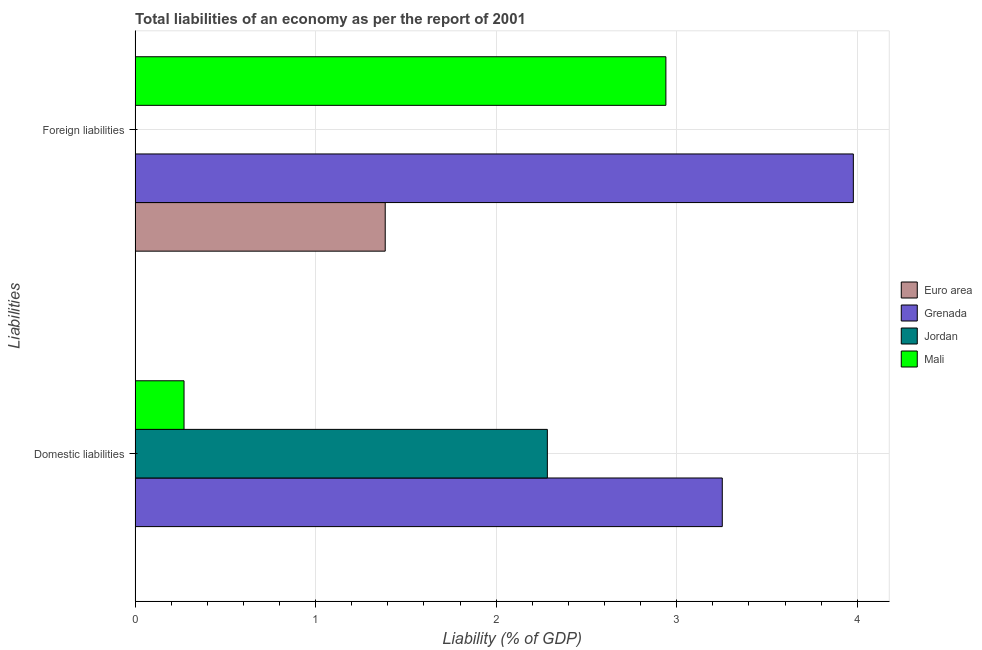How many different coloured bars are there?
Provide a short and direct response. 4. How many groups of bars are there?
Your response must be concise. 2. Are the number of bars per tick equal to the number of legend labels?
Ensure brevity in your answer.  No. Are the number of bars on each tick of the Y-axis equal?
Give a very brief answer. Yes. What is the label of the 1st group of bars from the top?
Provide a short and direct response. Foreign liabilities. What is the incurrence of domestic liabilities in Euro area?
Offer a terse response. 0. Across all countries, what is the maximum incurrence of foreign liabilities?
Offer a terse response. 3.98. In which country was the incurrence of domestic liabilities maximum?
Your answer should be compact. Grenada. What is the total incurrence of domestic liabilities in the graph?
Your answer should be compact. 5.81. What is the difference between the incurrence of domestic liabilities in Mali and that in Jordan?
Provide a short and direct response. -2.01. What is the difference between the incurrence of domestic liabilities in Grenada and the incurrence of foreign liabilities in Mali?
Your answer should be very brief. 0.31. What is the average incurrence of foreign liabilities per country?
Your response must be concise. 2.08. What is the difference between the incurrence of domestic liabilities and incurrence of foreign liabilities in Grenada?
Your answer should be very brief. -0.73. What is the ratio of the incurrence of domestic liabilities in Jordan to that in Grenada?
Your response must be concise. 0.7. Is the incurrence of foreign liabilities in Euro area less than that in Grenada?
Ensure brevity in your answer.  Yes. In how many countries, is the incurrence of foreign liabilities greater than the average incurrence of foreign liabilities taken over all countries?
Keep it short and to the point. 2. How many bars are there?
Provide a short and direct response. 6. Are all the bars in the graph horizontal?
Offer a terse response. Yes. Are the values on the major ticks of X-axis written in scientific E-notation?
Provide a short and direct response. No. Does the graph contain any zero values?
Your answer should be compact. Yes. Where does the legend appear in the graph?
Offer a terse response. Center right. How many legend labels are there?
Offer a terse response. 4. How are the legend labels stacked?
Your answer should be very brief. Vertical. What is the title of the graph?
Provide a short and direct response. Total liabilities of an economy as per the report of 2001. Does "Puerto Rico" appear as one of the legend labels in the graph?
Make the answer very short. No. What is the label or title of the X-axis?
Offer a terse response. Liability (% of GDP). What is the label or title of the Y-axis?
Your response must be concise. Liabilities. What is the Liability (% of GDP) of Grenada in Domestic liabilities?
Ensure brevity in your answer.  3.25. What is the Liability (% of GDP) in Jordan in Domestic liabilities?
Keep it short and to the point. 2.28. What is the Liability (% of GDP) of Mali in Domestic liabilities?
Your response must be concise. 0.27. What is the Liability (% of GDP) in Euro area in Foreign liabilities?
Provide a short and direct response. 1.39. What is the Liability (% of GDP) of Grenada in Foreign liabilities?
Offer a terse response. 3.98. What is the Liability (% of GDP) in Mali in Foreign liabilities?
Offer a very short reply. 2.94. Across all Liabilities, what is the maximum Liability (% of GDP) in Euro area?
Ensure brevity in your answer.  1.39. Across all Liabilities, what is the maximum Liability (% of GDP) in Grenada?
Your answer should be very brief. 3.98. Across all Liabilities, what is the maximum Liability (% of GDP) of Jordan?
Ensure brevity in your answer.  2.28. Across all Liabilities, what is the maximum Liability (% of GDP) of Mali?
Keep it short and to the point. 2.94. Across all Liabilities, what is the minimum Liability (% of GDP) in Euro area?
Provide a short and direct response. 0. Across all Liabilities, what is the minimum Liability (% of GDP) in Grenada?
Offer a very short reply. 3.25. Across all Liabilities, what is the minimum Liability (% of GDP) in Mali?
Keep it short and to the point. 0.27. What is the total Liability (% of GDP) in Euro area in the graph?
Provide a short and direct response. 1.39. What is the total Liability (% of GDP) in Grenada in the graph?
Provide a short and direct response. 7.23. What is the total Liability (% of GDP) in Jordan in the graph?
Your answer should be compact. 2.28. What is the total Liability (% of GDP) in Mali in the graph?
Your answer should be compact. 3.21. What is the difference between the Liability (% of GDP) in Grenada in Domestic liabilities and that in Foreign liabilities?
Provide a short and direct response. -0.73. What is the difference between the Liability (% of GDP) in Mali in Domestic liabilities and that in Foreign liabilities?
Offer a very short reply. -2.67. What is the difference between the Liability (% of GDP) of Grenada in Domestic liabilities and the Liability (% of GDP) of Mali in Foreign liabilities?
Offer a terse response. 0.31. What is the difference between the Liability (% of GDP) of Jordan in Domestic liabilities and the Liability (% of GDP) of Mali in Foreign liabilities?
Offer a very short reply. -0.66. What is the average Liability (% of GDP) of Euro area per Liabilities?
Provide a short and direct response. 0.69. What is the average Liability (% of GDP) in Grenada per Liabilities?
Ensure brevity in your answer.  3.62. What is the average Liability (% of GDP) in Jordan per Liabilities?
Provide a short and direct response. 1.14. What is the average Liability (% of GDP) of Mali per Liabilities?
Provide a succinct answer. 1.61. What is the difference between the Liability (% of GDP) of Grenada and Liability (% of GDP) of Jordan in Domestic liabilities?
Your answer should be very brief. 0.97. What is the difference between the Liability (% of GDP) of Grenada and Liability (% of GDP) of Mali in Domestic liabilities?
Give a very brief answer. 2.98. What is the difference between the Liability (% of GDP) of Jordan and Liability (% of GDP) of Mali in Domestic liabilities?
Provide a succinct answer. 2.01. What is the difference between the Liability (% of GDP) of Euro area and Liability (% of GDP) of Grenada in Foreign liabilities?
Your answer should be very brief. -2.59. What is the difference between the Liability (% of GDP) in Euro area and Liability (% of GDP) in Mali in Foreign liabilities?
Provide a short and direct response. -1.55. What is the difference between the Liability (% of GDP) of Grenada and Liability (% of GDP) of Mali in Foreign liabilities?
Offer a very short reply. 1.04. What is the ratio of the Liability (% of GDP) in Grenada in Domestic liabilities to that in Foreign liabilities?
Your response must be concise. 0.82. What is the ratio of the Liability (% of GDP) of Mali in Domestic liabilities to that in Foreign liabilities?
Provide a succinct answer. 0.09. What is the difference between the highest and the second highest Liability (% of GDP) in Grenada?
Provide a short and direct response. 0.73. What is the difference between the highest and the second highest Liability (% of GDP) of Mali?
Provide a short and direct response. 2.67. What is the difference between the highest and the lowest Liability (% of GDP) in Euro area?
Your answer should be compact. 1.39. What is the difference between the highest and the lowest Liability (% of GDP) in Grenada?
Give a very brief answer. 0.73. What is the difference between the highest and the lowest Liability (% of GDP) of Jordan?
Give a very brief answer. 2.28. What is the difference between the highest and the lowest Liability (% of GDP) in Mali?
Offer a very short reply. 2.67. 